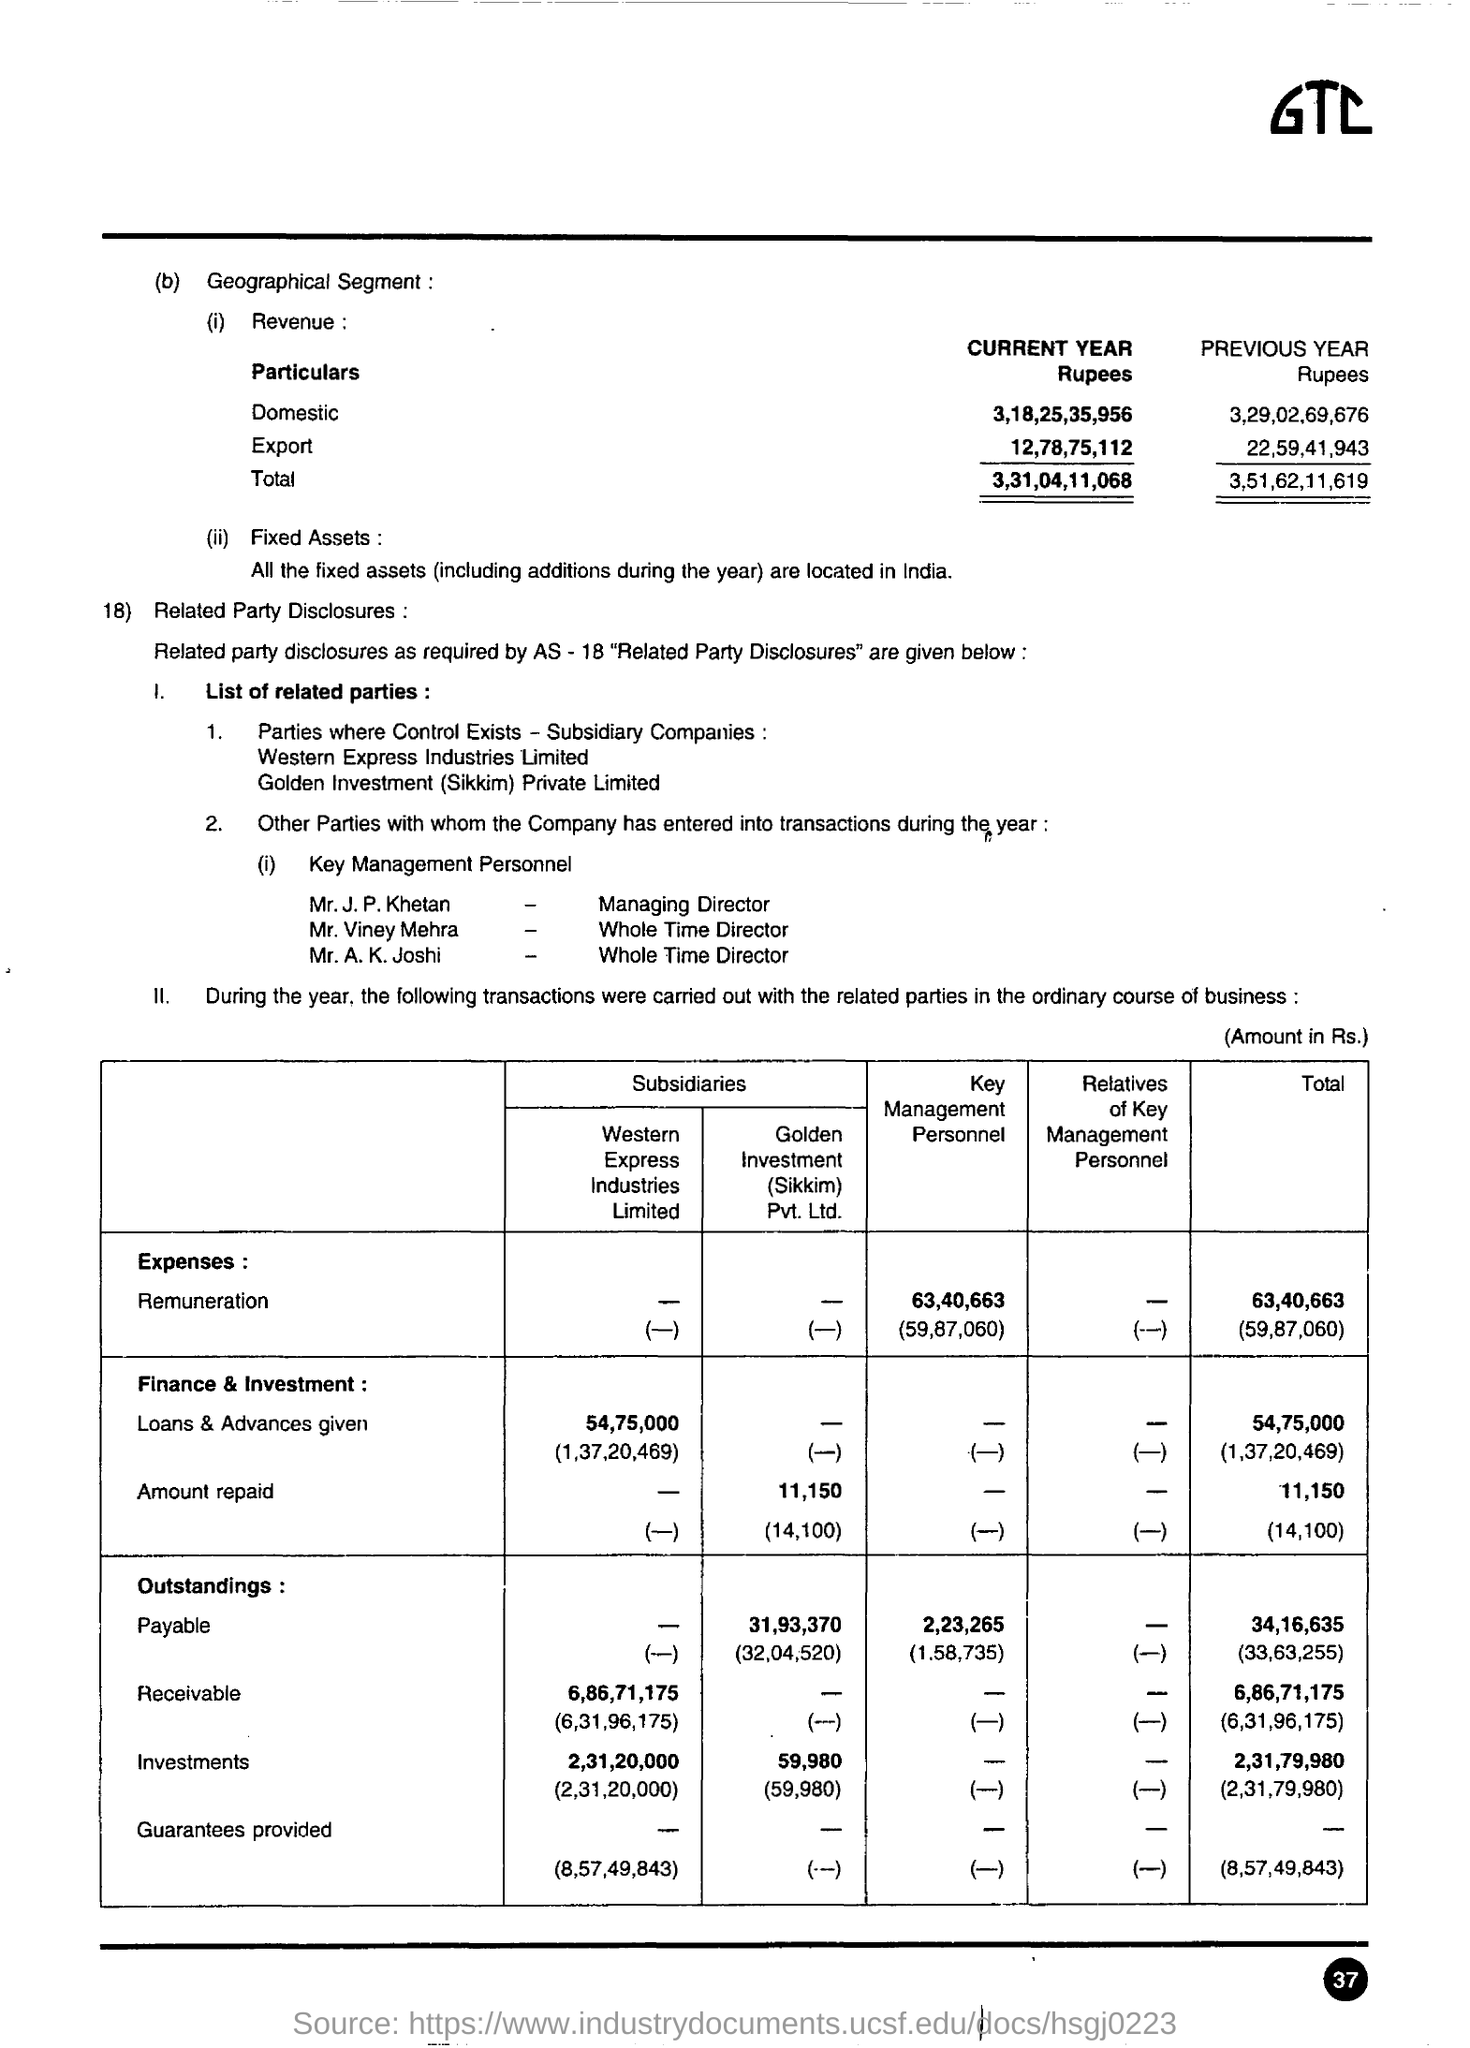Draw attention to some important aspects in this diagram. The total revenue for the current year is Rs. 3,31,04,11,068. The repayment amount for Golden Investment /(Sikkim) Pvt. Ltd. in the finance and investment sector is 11,150. The domestic revenue for the current year is 3,18,25,35,956 rupees. In the field of finance and investment, the total amount repaid is 11,150. The total revenue for the previous year was 3,51,62,11,619. 